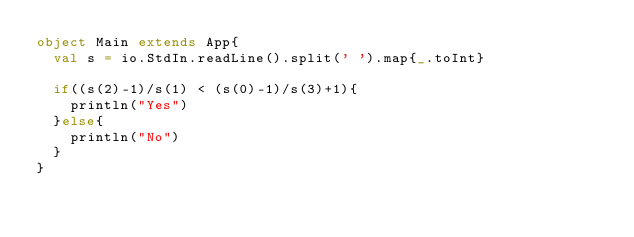<code> <loc_0><loc_0><loc_500><loc_500><_Scala_>object Main extends App{
  val s = io.StdIn.readLine().split(' ').map{_.toInt}

  if((s(2)-1)/s(1) < (s(0)-1)/s(3)+1){
    println("Yes")
  }else{
    println("No")
  }
}
</code> 